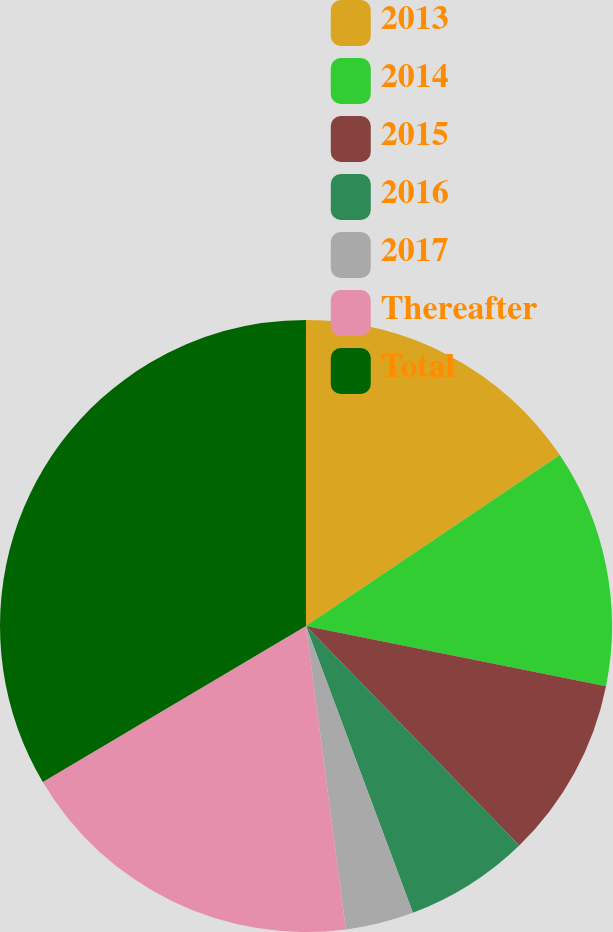Convert chart. <chart><loc_0><loc_0><loc_500><loc_500><pie_chart><fcel>2013<fcel>2014<fcel>2015<fcel>2016<fcel>2017<fcel>Thereafter<fcel>Total<nl><fcel>15.57%<fcel>12.58%<fcel>9.58%<fcel>6.59%<fcel>3.6%<fcel>18.56%<fcel>33.52%<nl></chart> 